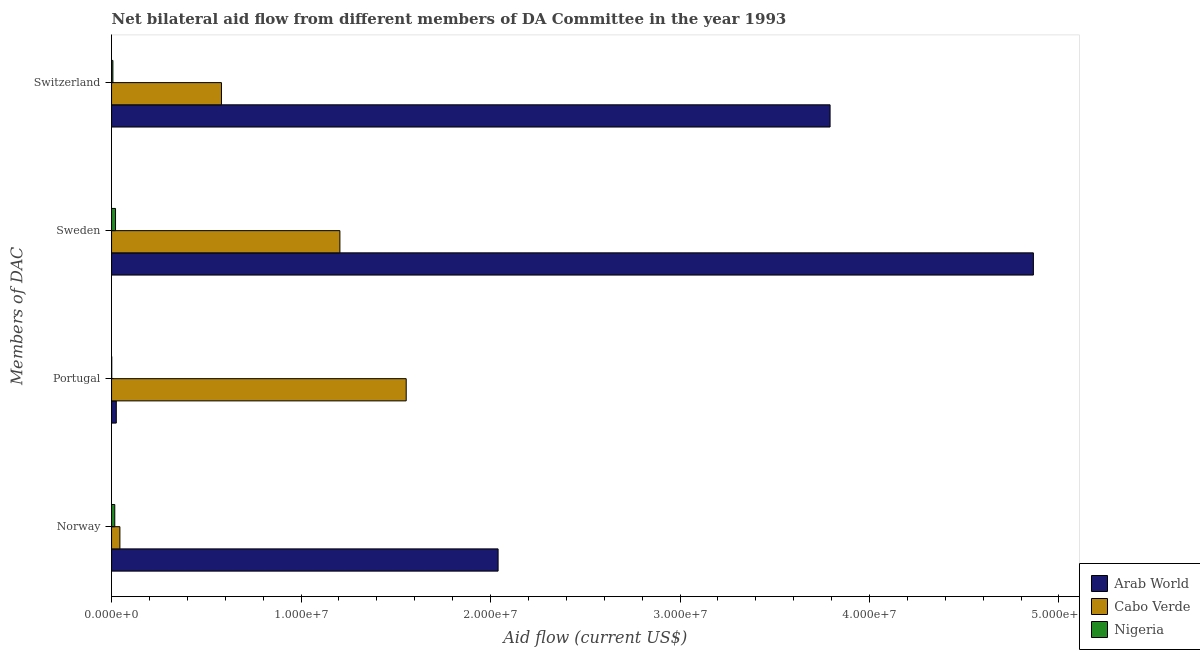Are the number of bars per tick equal to the number of legend labels?
Offer a terse response. Yes. How many bars are there on the 1st tick from the top?
Keep it short and to the point. 3. What is the amount of aid given by sweden in Cabo Verde?
Your answer should be very brief. 1.20e+07. Across all countries, what is the maximum amount of aid given by switzerland?
Ensure brevity in your answer.  3.79e+07. Across all countries, what is the minimum amount of aid given by portugal?
Your answer should be compact. 10000. In which country was the amount of aid given by portugal maximum?
Ensure brevity in your answer.  Cabo Verde. In which country was the amount of aid given by portugal minimum?
Offer a very short reply. Nigeria. What is the total amount of aid given by sweden in the graph?
Your response must be concise. 6.09e+07. What is the difference between the amount of aid given by portugal in Cabo Verde and that in Nigeria?
Offer a terse response. 1.55e+07. What is the difference between the amount of aid given by norway in Arab World and the amount of aid given by portugal in Cabo Verde?
Make the answer very short. 4.85e+06. What is the average amount of aid given by switzerland per country?
Your answer should be very brief. 1.46e+07. What is the difference between the amount of aid given by norway and amount of aid given by portugal in Cabo Verde?
Your answer should be very brief. -1.51e+07. In how many countries, is the amount of aid given by switzerland greater than 22000000 US$?
Your answer should be compact. 1. What is the ratio of the amount of aid given by sweden in Arab World to that in Nigeria?
Your response must be concise. 231.67. What is the difference between the highest and the second highest amount of aid given by norway?
Provide a short and direct response. 2.00e+07. What is the difference between the highest and the lowest amount of aid given by switzerland?
Make the answer very short. 3.78e+07. Is it the case that in every country, the sum of the amount of aid given by switzerland and amount of aid given by portugal is greater than the sum of amount of aid given by norway and amount of aid given by sweden?
Keep it short and to the point. No. What does the 2nd bar from the top in Norway represents?
Offer a very short reply. Cabo Verde. What does the 1st bar from the bottom in Portugal represents?
Offer a very short reply. Arab World. Is it the case that in every country, the sum of the amount of aid given by norway and amount of aid given by portugal is greater than the amount of aid given by sweden?
Provide a succinct answer. No. How many bars are there?
Your response must be concise. 12. How many countries are there in the graph?
Provide a short and direct response. 3. What is the difference between two consecutive major ticks on the X-axis?
Offer a terse response. 1.00e+07. Does the graph contain any zero values?
Provide a short and direct response. No. Does the graph contain grids?
Your response must be concise. No. Where does the legend appear in the graph?
Make the answer very short. Bottom right. How many legend labels are there?
Your answer should be very brief. 3. What is the title of the graph?
Offer a terse response. Net bilateral aid flow from different members of DA Committee in the year 1993. What is the label or title of the X-axis?
Provide a succinct answer. Aid flow (current US$). What is the label or title of the Y-axis?
Your answer should be very brief. Members of DAC. What is the Aid flow (current US$) in Arab World in Norway?
Give a very brief answer. 2.04e+07. What is the Aid flow (current US$) in Arab World in Portugal?
Offer a terse response. 2.50e+05. What is the Aid flow (current US$) of Cabo Verde in Portugal?
Your response must be concise. 1.56e+07. What is the Aid flow (current US$) in Arab World in Sweden?
Your response must be concise. 4.86e+07. What is the Aid flow (current US$) in Cabo Verde in Sweden?
Ensure brevity in your answer.  1.20e+07. What is the Aid flow (current US$) in Arab World in Switzerland?
Provide a succinct answer. 3.79e+07. What is the Aid flow (current US$) of Cabo Verde in Switzerland?
Give a very brief answer. 5.80e+06. Across all Members of DAC, what is the maximum Aid flow (current US$) in Arab World?
Give a very brief answer. 4.86e+07. Across all Members of DAC, what is the maximum Aid flow (current US$) of Cabo Verde?
Give a very brief answer. 1.56e+07. Across all Members of DAC, what is the minimum Aid flow (current US$) of Arab World?
Provide a succinct answer. 2.50e+05. Across all Members of DAC, what is the minimum Aid flow (current US$) in Nigeria?
Your response must be concise. 10000. What is the total Aid flow (current US$) in Arab World in the graph?
Your answer should be compact. 1.07e+08. What is the total Aid flow (current US$) of Cabo Verde in the graph?
Offer a very short reply. 3.38e+07. What is the total Aid flow (current US$) in Nigeria in the graph?
Your answer should be very brief. 4.60e+05. What is the difference between the Aid flow (current US$) of Arab World in Norway and that in Portugal?
Your answer should be very brief. 2.02e+07. What is the difference between the Aid flow (current US$) of Cabo Verde in Norway and that in Portugal?
Give a very brief answer. -1.51e+07. What is the difference between the Aid flow (current US$) in Nigeria in Norway and that in Portugal?
Keep it short and to the point. 1.60e+05. What is the difference between the Aid flow (current US$) in Arab World in Norway and that in Sweden?
Keep it short and to the point. -2.82e+07. What is the difference between the Aid flow (current US$) of Cabo Verde in Norway and that in Sweden?
Your answer should be very brief. -1.16e+07. What is the difference between the Aid flow (current US$) in Nigeria in Norway and that in Sweden?
Make the answer very short. -4.00e+04. What is the difference between the Aid flow (current US$) in Arab World in Norway and that in Switzerland?
Give a very brief answer. -1.75e+07. What is the difference between the Aid flow (current US$) in Cabo Verde in Norway and that in Switzerland?
Offer a very short reply. -5.36e+06. What is the difference between the Aid flow (current US$) in Nigeria in Norway and that in Switzerland?
Offer a very short reply. 1.00e+05. What is the difference between the Aid flow (current US$) of Arab World in Portugal and that in Sweden?
Make the answer very short. -4.84e+07. What is the difference between the Aid flow (current US$) of Cabo Verde in Portugal and that in Sweden?
Provide a succinct answer. 3.50e+06. What is the difference between the Aid flow (current US$) of Arab World in Portugal and that in Switzerland?
Your answer should be very brief. -3.77e+07. What is the difference between the Aid flow (current US$) in Cabo Verde in Portugal and that in Switzerland?
Your response must be concise. 9.75e+06. What is the difference between the Aid flow (current US$) in Arab World in Sweden and that in Switzerland?
Ensure brevity in your answer.  1.07e+07. What is the difference between the Aid flow (current US$) of Cabo Verde in Sweden and that in Switzerland?
Offer a terse response. 6.25e+06. What is the difference between the Aid flow (current US$) in Arab World in Norway and the Aid flow (current US$) in Cabo Verde in Portugal?
Make the answer very short. 4.85e+06. What is the difference between the Aid flow (current US$) of Arab World in Norway and the Aid flow (current US$) of Nigeria in Portugal?
Offer a very short reply. 2.04e+07. What is the difference between the Aid flow (current US$) in Cabo Verde in Norway and the Aid flow (current US$) in Nigeria in Portugal?
Ensure brevity in your answer.  4.30e+05. What is the difference between the Aid flow (current US$) in Arab World in Norway and the Aid flow (current US$) in Cabo Verde in Sweden?
Your response must be concise. 8.35e+06. What is the difference between the Aid flow (current US$) of Arab World in Norway and the Aid flow (current US$) of Nigeria in Sweden?
Your answer should be very brief. 2.02e+07. What is the difference between the Aid flow (current US$) in Arab World in Norway and the Aid flow (current US$) in Cabo Verde in Switzerland?
Your answer should be compact. 1.46e+07. What is the difference between the Aid flow (current US$) of Arab World in Norway and the Aid flow (current US$) of Nigeria in Switzerland?
Offer a very short reply. 2.03e+07. What is the difference between the Aid flow (current US$) of Cabo Verde in Norway and the Aid flow (current US$) of Nigeria in Switzerland?
Provide a succinct answer. 3.70e+05. What is the difference between the Aid flow (current US$) of Arab World in Portugal and the Aid flow (current US$) of Cabo Verde in Sweden?
Provide a succinct answer. -1.18e+07. What is the difference between the Aid flow (current US$) in Arab World in Portugal and the Aid flow (current US$) in Nigeria in Sweden?
Provide a succinct answer. 4.00e+04. What is the difference between the Aid flow (current US$) in Cabo Verde in Portugal and the Aid flow (current US$) in Nigeria in Sweden?
Make the answer very short. 1.53e+07. What is the difference between the Aid flow (current US$) of Arab World in Portugal and the Aid flow (current US$) of Cabo Verde in Switzerland?
Give a very brief answer. -5.55e+06. What is the difference between the Aid flow (current US$) of Arab World in Portugal and the Aid flow (current US$) of Nigeria in Switzerland?
Provide a succinct answer. 1.80e+05. What is the difference between the Aid flow (current US$) of Cabo Verde in Portugal and the Aid flow (current US$) of Nigeria in Switzerland?
Provide a succinct answer. 1.55e+07. What is the difference between the Aid flow (current US$) of Arab World in Sweden and the Aid flow (current US$) of Cabo Verde in Switzerland?
Ensure brevity in your answer.  4.28e+07. What is the difference between the Aid flow (current US$) of Arab World in Sweden and the Aid flow (current US$) of Nigeria in Switzerland?
Make the answer very short. 4.86e+07. What is the difference between the Aid flow (current US$) in Cabo Verde in Sweden and the Aid flow (current US$) in Nigeria in Switzerland?
Offer a very short reply. 1.20e+07. What is the average Aid flow (current US$) of Arab World per Members of DAC?
Keep it short and to the point. 2.68e+07. What is the average Aid flow (current US$) of Cabo Verde per Members of DAC?
Provide a succinct answer. 8.46e+06. What is the average Aid flow (current US$) in Nigeria per Members of DAC?
Your response must be concise. 1.15e+05. What is the difference between the Aid flow (current US$) of Arab World and Aid flow (current US$) of Cabo Verde in Norway?
Offer a very short reply. 2.00e+07. What is the difference between the Aid flow (current US$) in Arab World and Aid flow (current US$) in Nigeria in Norway?
Keep it short and to the point. 2.02e+07. What is the difference between the Aid flow (current US$) in Arab World and Aid flow (current US$) in Cabo Verde in Portugal?
Ensure brevity in your answer.  -1.53e+07. What is the difference between the Aid flow (current US$) of Arab World and Aid flow (current US$) of Nigeria in Portugal?
Make the answer very short. 2.40e+05. What is the difference between the Aid flow (current US$) of Cabo Verde and Aid flow (current US$) of Nigeria in Portugal?
Offer a very short reply. 1.55e+07. What is the difference between the Aid flow (current US$) of Arab World and Aid flow (current US$) of Cabo Verde in Sweden?
Provide a short and direct response. 3.66e+07. What is the difference between the Aid flow (current US$) in Arab World and Aid flow (current US$) in Nigeria in Sweden?
Ensure brevity in your answer.  4.84e+07. What is the difference between the Aid flow (current US$) of Cabo Verde and Aid flow (current US$) of Nigeria in Sweden?
Offer a very short reply. 1.18e+07. What is the difference between the Aid flow (current US$) of Arab World and Aid flow (current US$) of Cabo Verde in Switzerland?
Provide a succinct answer. 3.21e+07. What is the difference between the Aid flow (current US$) in Arab World and Aid flow (current US$) in Nigeria in Switzerland?
Give a very brief answer. 3.78e+07. What is the difference between the Aid flow (current US$) in Cabo Verde and Aid flow (current US$) in Nigeria in Switzerland?
Offer a very short reply. 5.73e+06. What is the ratio of the Aid flow (current US$) of Arab World in Norway to that in Portugal?
Offer a very short reply. 81.6. What is the ratio of the Aid flow (current US$) of Cabo Verde in Norway to that in Portugal?
Ensure brevity in your answer.  0.03. What is the ratio of the Aid flow (current US$) of Arab World in Norway to that in Sweden?
Your response must be concise. 0.42. What is the ratio of the Aid flow (current US$) of Cabo Verde in Norway to that in Sweden?
Your answer should be compact. 0.04. What is the ratio of the Aid flow (current US$) in Nigeria in Norway to that in Sweden?
Ensure brevity in your answer.  0.81. What is the ratio of the Aid flow (current US$) in Arab World in Norway to that in Switzerland?
Keep it short and to the point. 0.54. What is the ratio of the Aid flow (current US$) in Cabo Verde in Norway to that in Switzerland?
Offer a terse response. 0.08. What is the ratio of the Aid flow (current US$) in Nigeria in Norway to that in Switzerland?
Keep it short and to the point. 2.43. What is the ratio of the Aid flow (current US$) in Arab World in Portugal to that in Sweden?
Make the answer very short. 0.01. What is the ratio of the Aid flow (current US$) of Cabo Verde in Portugal to that in Sweden?
Your answer should be compact. 1.29. What is the ratio of the Aid flow (current US$) of Nigeria in Portugal to that in Sweden?
Your answer should be compact. 0.05. What is the ratio of the Aid flow (current US$) of Arab World in Portugal to that in Switzerland?
Provide a succinct answer. 0.01. What is the ratio of the Aid flow (current US$) in Cabo Verde in Portugal to that in Switzerland?
Your answer should be compact. 2.68. What is the ratio of the Aid flow (current US$) of Nigeria in Portugal to that in Switzerland?
Make the answer very short. 0.14. What is the ratio of the Aid flow (current US$) in Arab World in Sweden to that in Switzerland?
Your answer should be compact. 1.28. What is the ratio of the Aid flow (current US$) in Cabo Verde in Sweden to that in Switzerland?
Provide a succinct answer. 2.08. What is the difference between the highest and the second highest Aid flow (current US$) in Arab World?
Provide a succinct answer. 1.07e+07. What is the difference between the highest and the second highest Aid flow (current US$) in Cabo Verde?
Your answer should be very brief. 3.50e+06. What is the difference between the highest and the second highest Aid flow (current US$) of Nigeria?
Keep it short and to the point. 4.00e+04. What is the difference between the highest and the lowest Aid flow (current US$) in Arab World?
Your answer should be compact. 4.84e+07. What is the difference between the highest and the lowest Aid flow (current US$) in Cabo Verde?
Keep it short and to the point. 1.51e+07. What is the difference between the highest and the lowest Aid flow (current US$) in Nigeria?
Ensure brevity in your answer.  2.00e+05. 